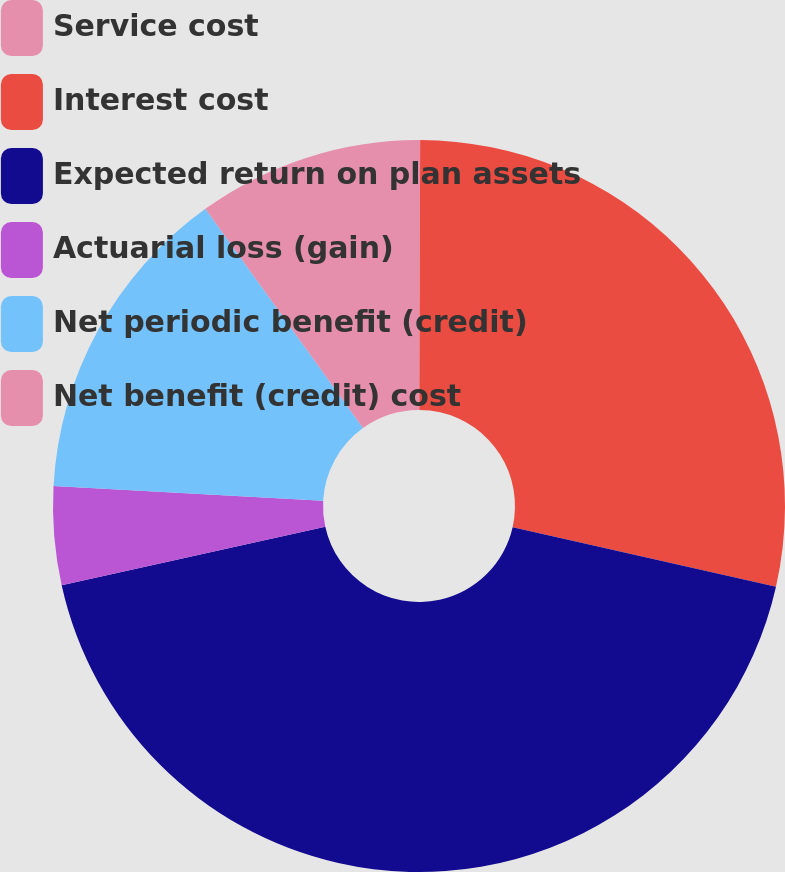Convert chart to OTSL. <chart><loc_0><loc_0><loc_500><loc_500><pie_chart><fcel>Service cost<fcel>Interest cost<fcel>Expected return on plan assets<fcel>Actuarial loss (gain)<fcel>Net periodic benefit (credit)<fcel>Net benefit (credit) cost<nl><fcel>0.05%<fcel>28.49%<fcel>42.99%<fcel>4.34%<fcel>14.21%<fcel>9.92%<nl></chart> 